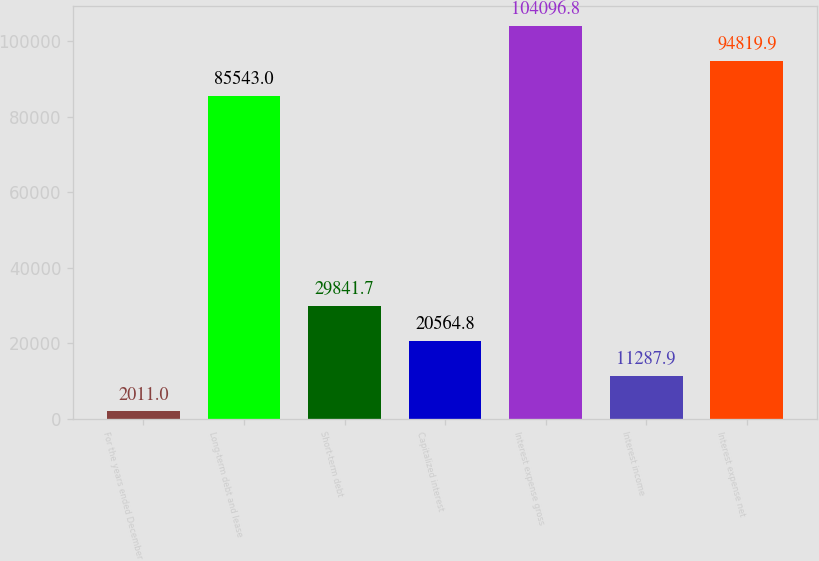<chart> <loc_0><loc_0><loc_500><loc_500><bar_chart><fcel>For the years ended December<fcel>Long-term debt and lease<fcel>Short-term debt<fcel>Capitalized interest<fcel>Interest expense gross<fcel>Interest income<fcel>Interest expense net<nl><fcel>2011<fcel>85543<fcel>29841.7<fcel>20564.8<fcel>104097<fcel>11287.9<fcel>94819.9<nl></chart> 